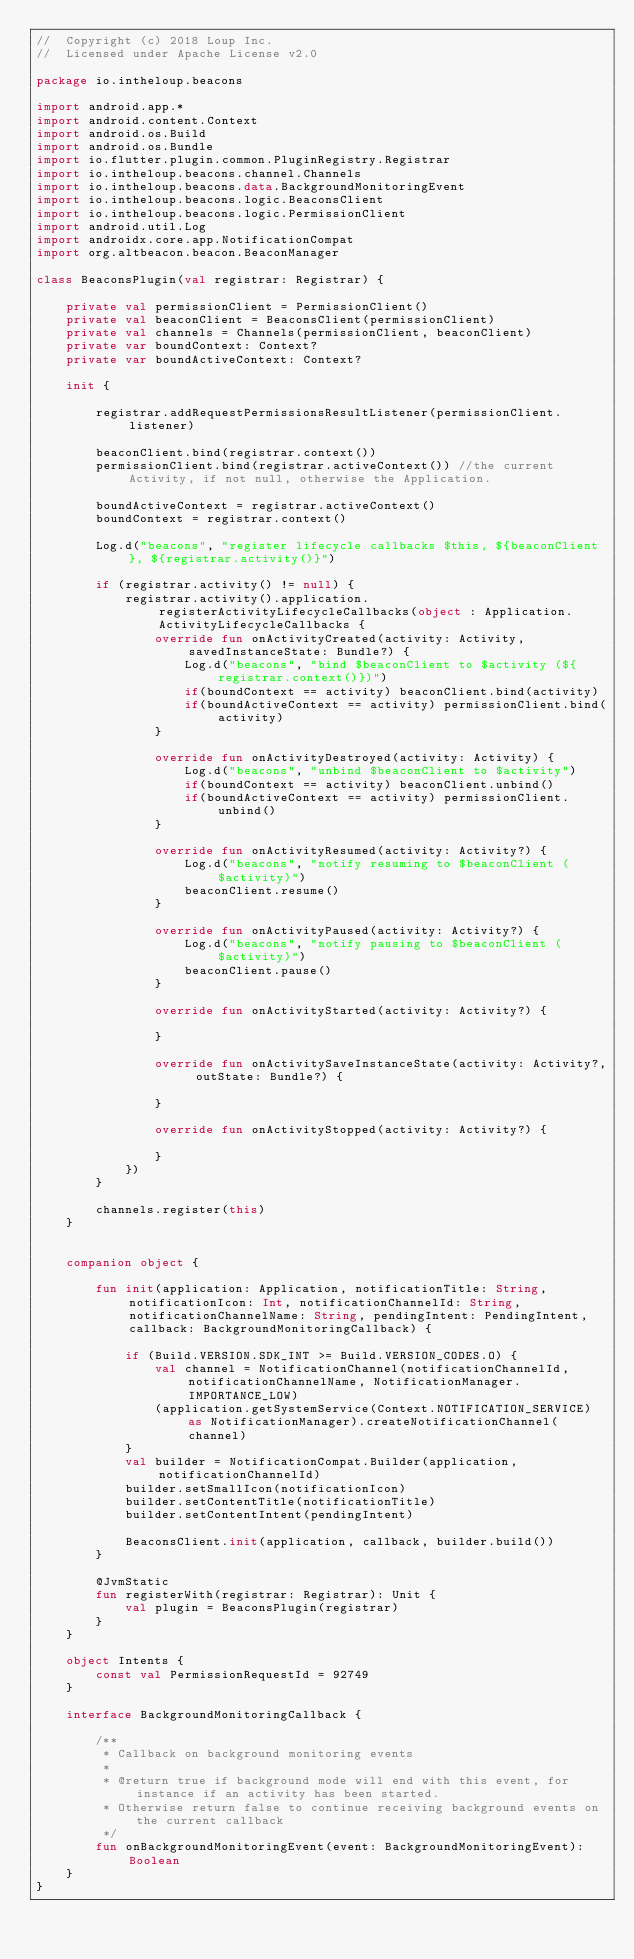Convert code to text. <code><loc_0><loc_0><loc_500><loc_500><_Kotlin_>//  Copyright (c) 2018 Loup Inc.
//  Licensed under Apache License v2.0

package io.intheloup.beacons

import android.app.*
import android.content.Context
import android.os.Build
import android.os.Bundle
import io.flutter.plugin.common.PluginRegistry.Registrar
import io.intheloup.beacons.channel.Channels
import io.intheloup.beacons.data.BackgroundMonitoringEvent
import io.intheloup.beacons.logic.BeaconsClient
import io.intheloup.beacons.logic.PermissionClient
import android.util.Log
import androidx.core.app.NotificationCompat
import org.altbeacon.beacon.BeaconManager

class BeaconsPlugin(val registrar: Registrar) {

    private val permissionClient = PermissionClient()
    private val beaconClient = BeaconsClient(permissionClient)
    private val channels = Channels(permissionClient, beaconClient)
    private var boundContext: Context?
    private var boundActiveContext: Context?

    init {

        registrar.addRequestPermissionsResultListener(permissionClient.listener)

        beaconClient.bind(registrar.context())
        permissionClient.bind(registrar.activeContext()) //the current Activity, if not null, otherwise the Application.

        boundActiveContext = registrar.activeContext()
        boundContext = registrar.context()

        Log.d("beacons", "register lifecycle callbacks $this, ${beaconClient}, ${registrar.activity()}")

        if (registrar.activity() != null) {
            registrar.activity().application.registerActivityLifecycleCallbacks(object : Application.ActivityLifecycleCallbacks {
                override fun onActivityCreated(activity: Activity, savedInstanceState: Bundle?) {
                    Log.d("beacons", "bind $beaconClient to $activity (${registrar.context()})")
                    if(boundContext == activity) beaconClient.bind(activity)
                    if(boundActiveContext == activity) permissionClient.bind(activity)
                }

                override fun onActivityDestroyed(activity: Activity) {
                    Log.d("beacons", "unbind $beaconClient to $activity")
                    if(boundContext == activity) beaconClient.unbind()
                    if(boundActiveContext == activity) permissionClient.unbind()
                }

                override fun onActivityResumed(activity: Activity?) {
                    Log.d("beacons", "notify resuming to $beaconClient ($activity)")
                    beaconClient.resume()
                }

                override fun onActivityPaused(activity: Activity?) {
                    Log.d("beacons", "notify pausing to $beaconClient ($activity)")
                    beaconClient.pause()
                }

                override fun onActivityStarted(activity: Activity?) {

                }

                override fun onActivitySaveInstanceState(activity: Activity?, outState: Bundle?) {

                }

                override fun onActivityStopped(activity: Activity?) {

                }
            })
        }

        channels.register(this)
    }


    companion object {

        fun init(application: Application, notificationTitle: String, notificationIcon: Int, notificationChannelId: String, notificationChannelName: String, pendingIntent: PendingIntent, callback: BackgroundMonitoringCallback) {

            if (Build.VERSION.SDK_INT >= Build.VERSION_CODES.O) {
                val channel = NotificationChannel(notificationChannelId, notificationChannelName, NotificationManager.IMPORTANCE_LOW)
                (application.getSystemService(Context.NOTIFICATION_SERVICE) as NotificationManager).createNotificationChannel(channel)
            }
            val builder = NotificationCompat.Builder(application, notificationChannelId)
            builder.setSmallIcon(notificationIcon)
            builder.setContentTitle(notificationTitle)
            builder.setContentIntent(pendingIntent)

            BeaconsClient.init(application, callback, builder.build())
        }

        @JvmStatic
        fun registerWith(registrar: Registrar): Unit {
            val plugin = BeaconsPlugin(registrar)
        }
    }

    object Intents {
        const val PermissionRequestId = 92749
    }

    interface BackgroundMonitoringCallback {

        /**
         * Callback on background monitoring events
         *
         * @return true if background mode will end with this event, for instance if an activity has been started.
         * Otherwise return false to continue receiving background events on the current callback
         */
        fun onBackgroundMonitoringEvent(event: BackgroundMonitoringEvent): Boolean
    }
}
</code> 